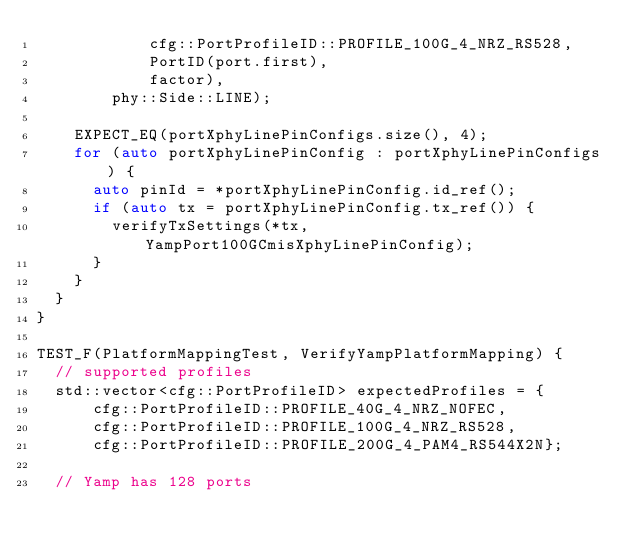<code> <loc_0><loc_0><loc_500><loc_500><_C++_>            cfg::PortProfileID::PROFILE_100G_4_NRZ_RS528,
            PortID(port.first),
            factor),
        phy::Side::LINE);

    EXPECT_EQ(portXphyLinePinConfigs.size(), 4);
    for (auto portXphyLinePinConfig : portXphyLinePinConfigs) {
      auto pinId = *portXphyLinePinConfig.id_ref();
      if (auto tx = portXphyLinePinConfig.tx_ref()) {
        verifyTxSettings(*tx, YampPort100GCmisXphyLinePinConfig);
      }
    }
  }
}

TEST_F(PlatformMappingTest, VerifyYampPlatformMapping) {
  // supported profiles
  std::vector<cfg::PortProfileID> expectedProfiles = {
      cfg::PortProfileID::PROFILE_40G_4_NRZ_NOFEC,
      cfg::PortProfileID::PROFILE_100G_4_NRZ_RS528,
      cfg::PortProfileID::PROFILE_200G_4_PAM4_RS544X2N};

  // Yamp has 128 ports</code> 